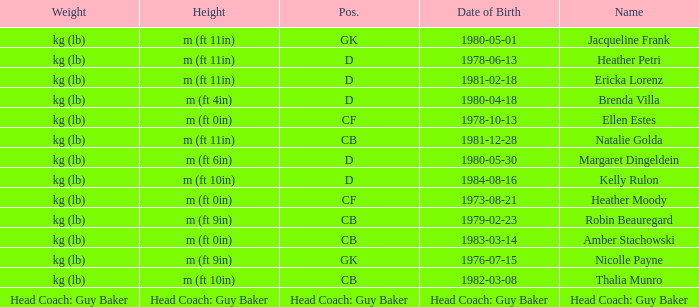Born on 1983-03-14, what is the cb's name? Amber Stachowski. 